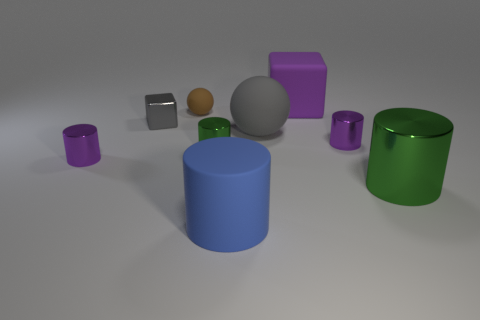What is the tiny brown ball made of?
Give a very brief answer. Rubber. How many tiny green cylinders are there?
Give a very brief answer. 1. Is the color of the tiny cylinder left of the tiny green object the same as the large cylinder to the left of the large green cylinder?
Your answer should be compact. No. There is a sphere that is the same color as the tiny cube; what is its size?
Your answer should be very brief. Large. How many other things are the same size as the gray ball?
Give a very brief answer. 3. There is a small metal object behind the large gray thing; what color is it?
Make the answer very short. Gray. Does the purple thing that is behind the small shiny block have the same material as the brown object?
Give a very brief answer. Yes. How many tiny shiny objects are in front of the big gray rubber sphere and on the left side of the big matte sphere?
Provide a short and direct response. 2. What color is the large rubber thing that is in front of the green metal object that is in front of the tiny purple metal cylinder left of the large purple block?
Offer a terse response. Blue. How many other objects are there of the same shape as the purple matte thing?
Your answer should be compact. 1. 